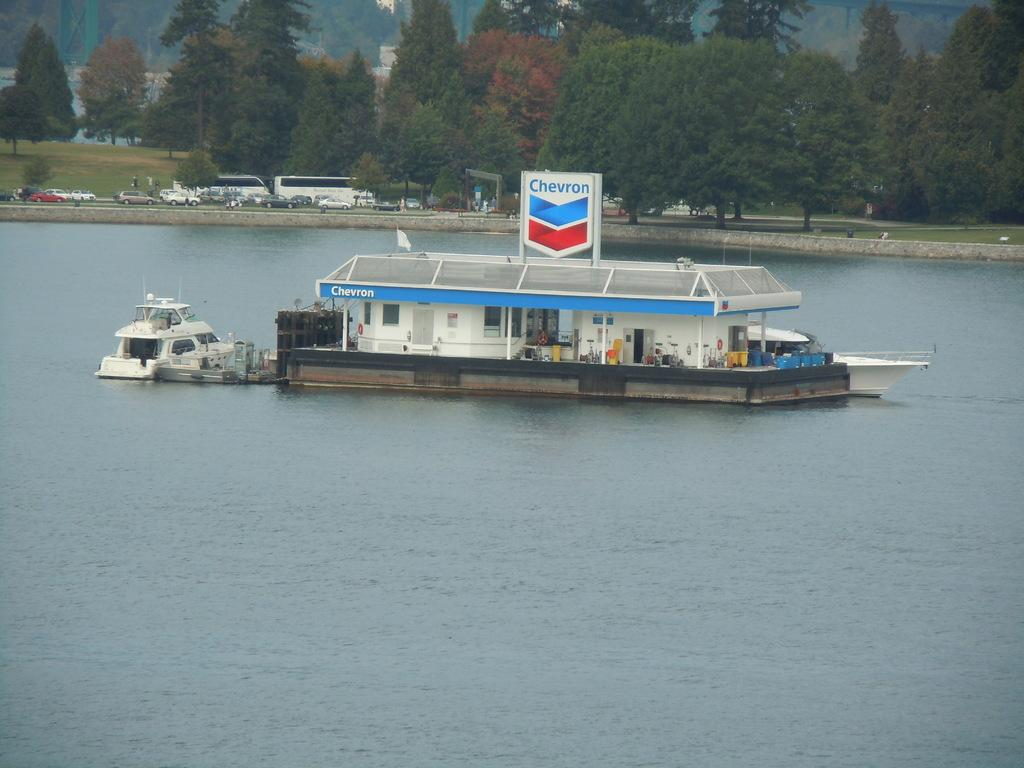What is the main subject of the image? The main subject of the image is a boat. What is the boat doing in the image? The boat is selling something in the image. Where is the boat located? The boat is on a lake in the image. What can be seen in the background of the image? There is a road and trees in the background of the image. What is happening on the road in the background? Vehicles are moving on the road in the background. What type of card is being used to purchase the lettuce from the boat? There is no card or lettuce present in the image. The boat is selling something, but the specific item is not mentioned or visible. 